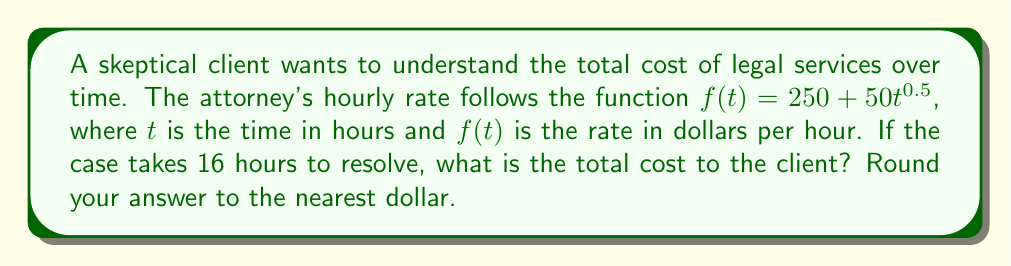Solve this math problem. To find the total cost, we need to calculate the area under the curve of $f(t)$ from $t=0$ to $t=16$. This is done using a definite integral:

1) Set up the integral:
   $$\int_0^{16} (250 + 50t^{0.5}) dt$$

2) Integrate the function:
   $$\left[250t + 50 \cdot \frac{2}{3}t^{1.5}\right]_0^{16}$$

3) Evaluate the integral:
   $$\left(250 \cdot 16 + 50 \cdot \frac{2}{3} \cdot 16^{1.5}\right) - \left(250 \cdot 0 + 50 \cdot \frac{2}{3} \cdot 0^{1.5}\right)$$

4) Simplify:
   $$4000 + \frac{100}{3} \cdot 64 = 4000 + 2133.33$$

5) Add the results:
   $$6133.33$$

6) Round to the nearest dollar:
   $$6133$$
Answer: $6133 